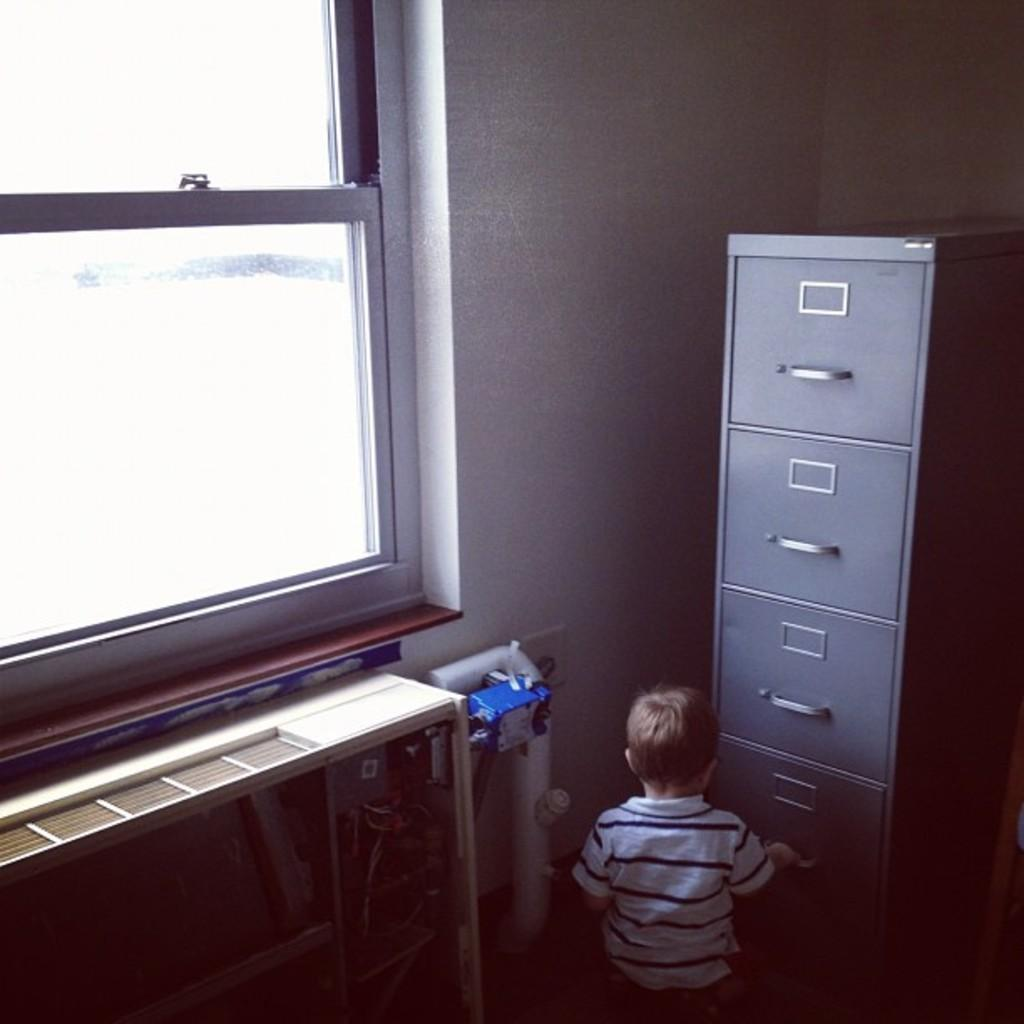Who is the main subject in the image? There is a boy in the image. What is located to the right of the boy? There are drawers to the right of the boy. What can be seen to the left of the boy? There is a wall with a window to the left of the boy. What type of bike is the boy riding in the image? There is no bike present in the image; the boy is not riding a bike. 